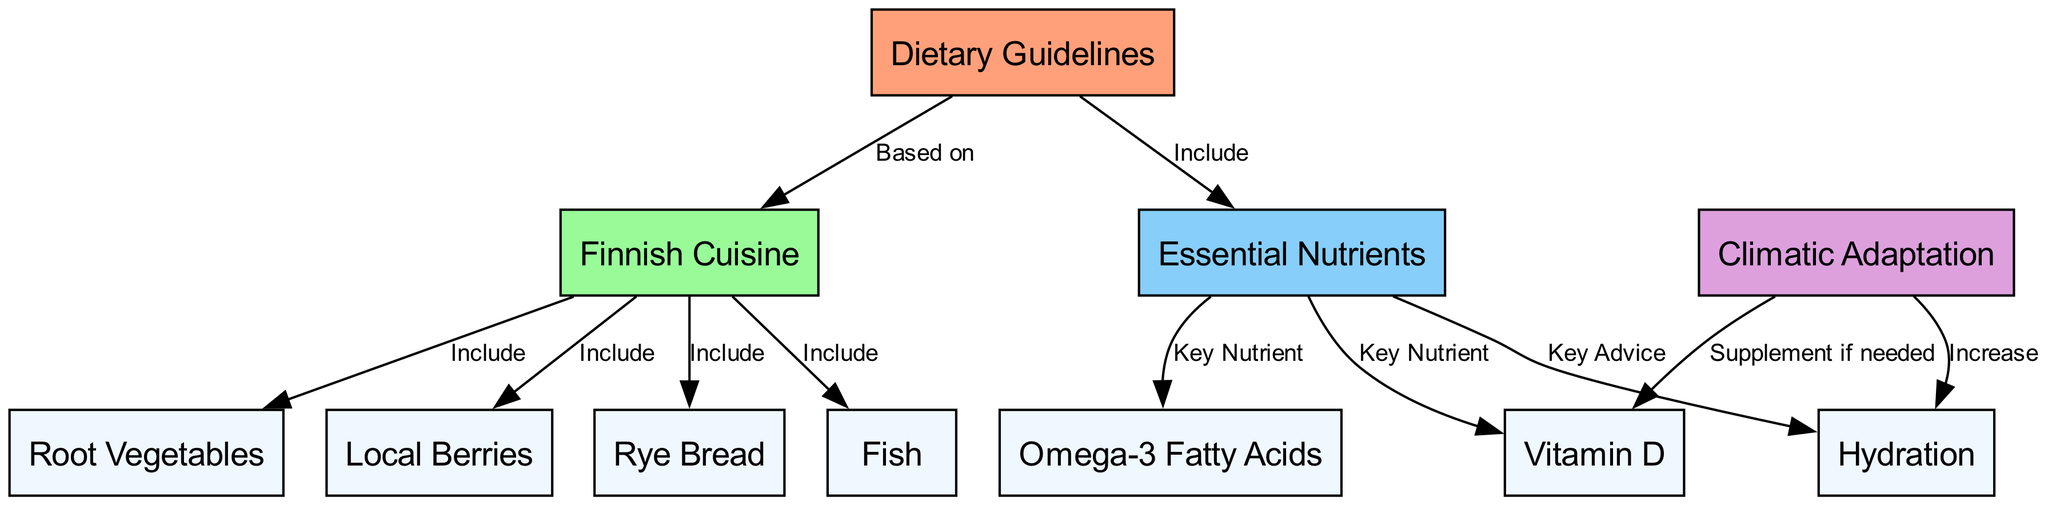What are the Dietary Guidelines based on? The diagram shows a direct edge from the "Dietary Guidelines" node to the "Finnish Cuisine" node labeled "Based on". This indicates that the dietary guidelines are informed by or derived from Finnish cuisine.
Answer: Finnish Cuisine How many key nutrients are identified in the diagram? The "Essential Nutrients" node has direct edges leading to "Vitamin D", "Omega-3 Fatty Acids", and "Hydration". Counting these three nodes gives a total of three key nutrients identified in this diagram.
Answer: 3 What should be included under Finnish Cuisine? The diagram lists several nodes connected to "Finnish Cuisine": "Local Berries", "Rye Bread", "Fish", and "Root Vegetables". These represent food items or groups included in Finnish cuisine.
Answer: Local Berries, Rye Bread, Fish, Root Vegetables Which nutrient should be supplemented if needed? The diagram has an edge from "Climatic Adaptation" to "Vitamin D", labeled "Supplement if needed". This infers that Vitamin D is a key nutrient that may require supplementation depending on climatic adaptation needs.
Answer: Vitamin D What is the key advice related to hydration? There is an edge connecting "Essential Nutrients" to "Hydration", labeled "Key Advice". This indicates that hydration is a critical component of dietary advice provided in the diagram.
Answer: Increase 